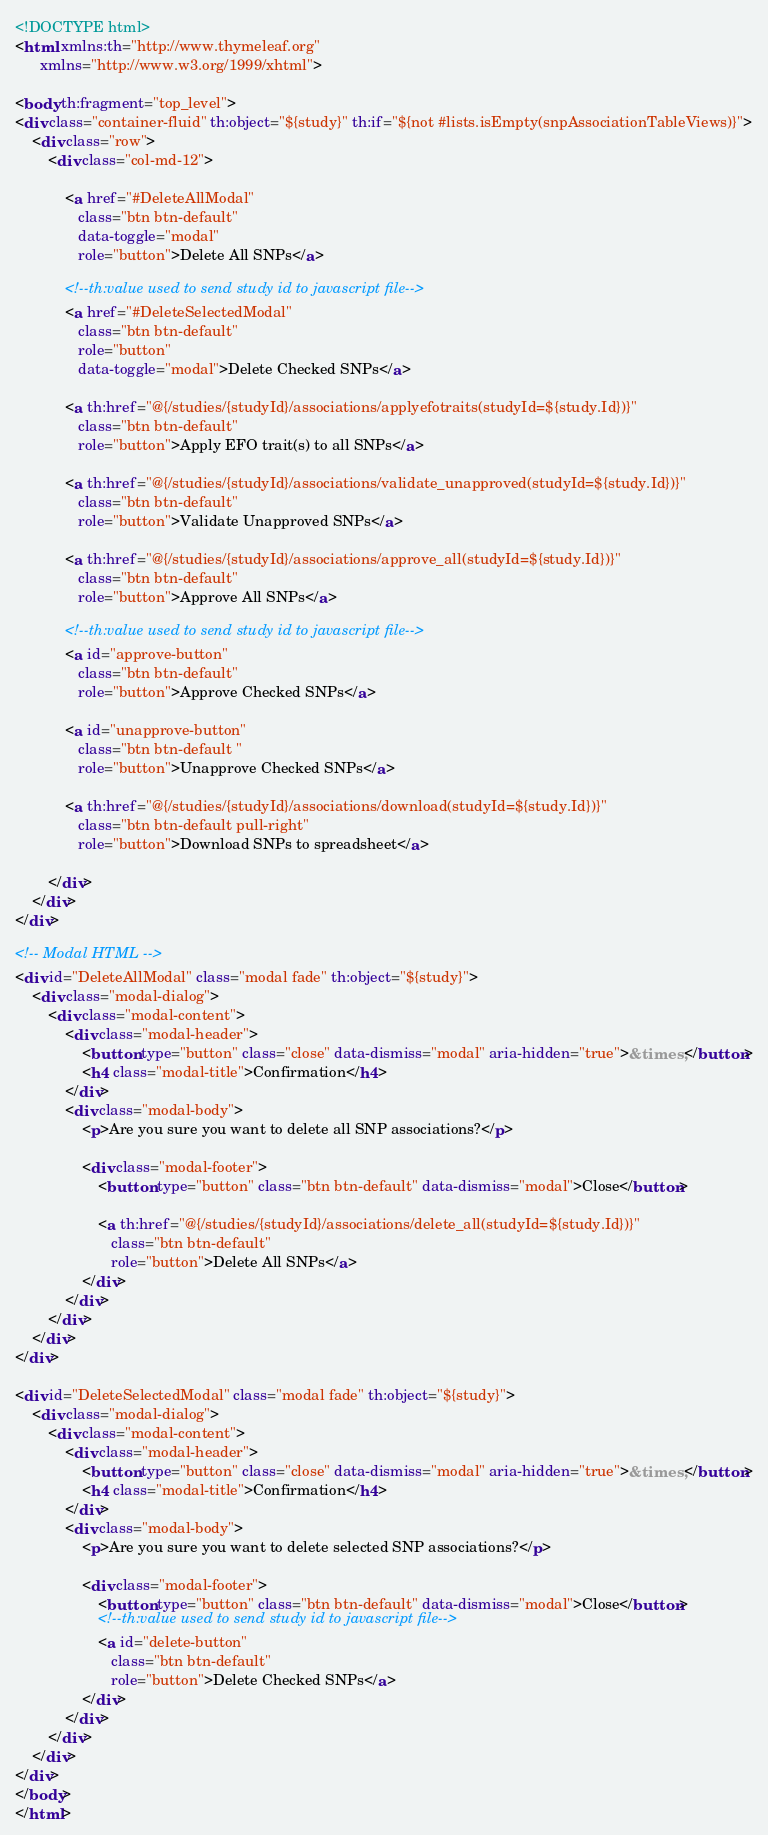<code> <loc_0><loc_0><loc_500><loc_500><_HTML_><!DOCTYPE html>
<html xmlns:th="http://www.thymeleaf.org"
      xmlns="http://www.w3.org/1999/xhtml">

<body th:fragment="top_level">
<div class="container-fluid" th:object="${study}" th:if="${not #lists.isEmpty(snpAssociationTableViews)}">
    <div class="row">
        <div class="col-md-12">

            <a href="#DeleteAllModal"
               class="btn btn-default"
               data-toggle="modal"
               role="button">Delete All SNPs</a>

            <!--th:value used to send study id to javascript file-->
            <a href="#DeleteSelectedModal"
               class="btn btn-default"
               role="button"
               data-toggle="modal">Delete Checked SNPs</a>

            <a th:href="@{/studies/{studyId}/associations/applyefotraits(studyId=${study.Id})}"
               class="btn btn-default"
               role="button">Apply EFO trait(s) to all SNPs</a>

            <a th:href="@{/studies/{studyId}/associations/validate_unapproved(studyId=${study.Id})}"
               class="btn btn-default"
               role="button">Validate Unapproved SNPs</a>
            
            <a th:href="@{/studies/{studyId}/associations/approve_all(studyId=${study.Id})}"
               class="btn btn-default"
               role="button">Approve All SNPs</a>

            <!--th:value used to send study id to javascript file-->
            <a id="approve-button"
               class="btn btn-default"
               role="button">Approve Checked SNPs</a>

            <a id="unapprove-button"
               class="btn btn-default "
               role="button">Unapprove Checked SNPs</a>

            <a th:href="@{/studies/{studyId}/associations/download(studyId=${study.Id})}"
               class="btn btn-default pull-right"
               role="button">Download SNPs to spreadsheet</a>

        </div>
    </div>
</div>

<!-- Modal HTML -->
<div id="DeleteAllModal" class="modal fade" th:object="${study}">
    <div class="modal-dialog">
        <div class="modal-content">
            <div class="modal-header">
                <button type="button" class="close" data-dismiss="modal" aria-hidden="true">&times;</button>
                <h4 class="modal-title">Confirmation</h4>
            </div>
            <div class="modal-body">
                <p>Are you sure you want to delete all SNP associations?</p>

                <div class="modal-footer">
                    <button type="button" class="btn btn-default" data-dismiss="modal">Close</button>

                    <a th:href="@{/studies/{studyId}/associations/delete_all(studyId=${study.Id})}"
                       class="btn btn-default"
                       role="button">Delete All SNPs</a>
                </div>
            </div>
        </div>
    </div>
</div>

<div id="DeleteSelectedModal" class="modal fade" th:object="${study}">
    <div class="modal-dialog">
        <div class="modal-content">
            <div class="modal-header">
                <button type="button" class="close" data-dismiss="modal" aria-hidden="true">&times;</button>
                <h4 class="modal-title">Confirmation</h4>
            </div>
            <div class="modal-body">
                <p>Are you sure you want to delete selected SNP associations?</p>

                <div class="modal-footer">
                    <button type="button" class="btn btn-default" data-dismiss="modal">Close</button>
                    <!--th:value used to send study id to javascript file-->
                    <a id="delete-button"
                       class="btn btn-default"
                       role="button">Delete Checked SNPs</a>
                </div>
            </div>
        </div>
    </div>
</div>
</body>
</html></code> 